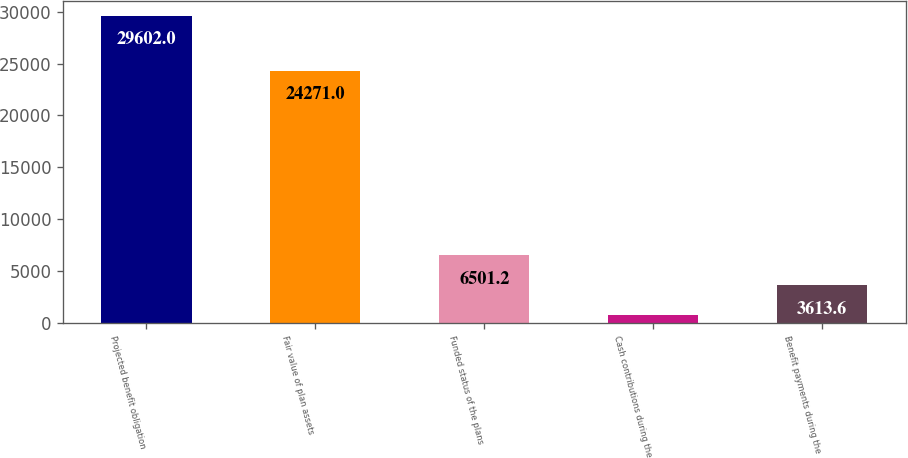<chart> <loc_0><loc_0><loc_500><loc_500><bar_chart><fcel>Projected benefit obligation<fcel>Fair value of plan assets<fcel>Funded status of the plans<fcel>Cash contributions during the<fcel>Benefit payments during the<nl><fcel>29602<fcel>24271<fcel>6501.2<fcel>726<fcel>3613.6<nl></chart> 